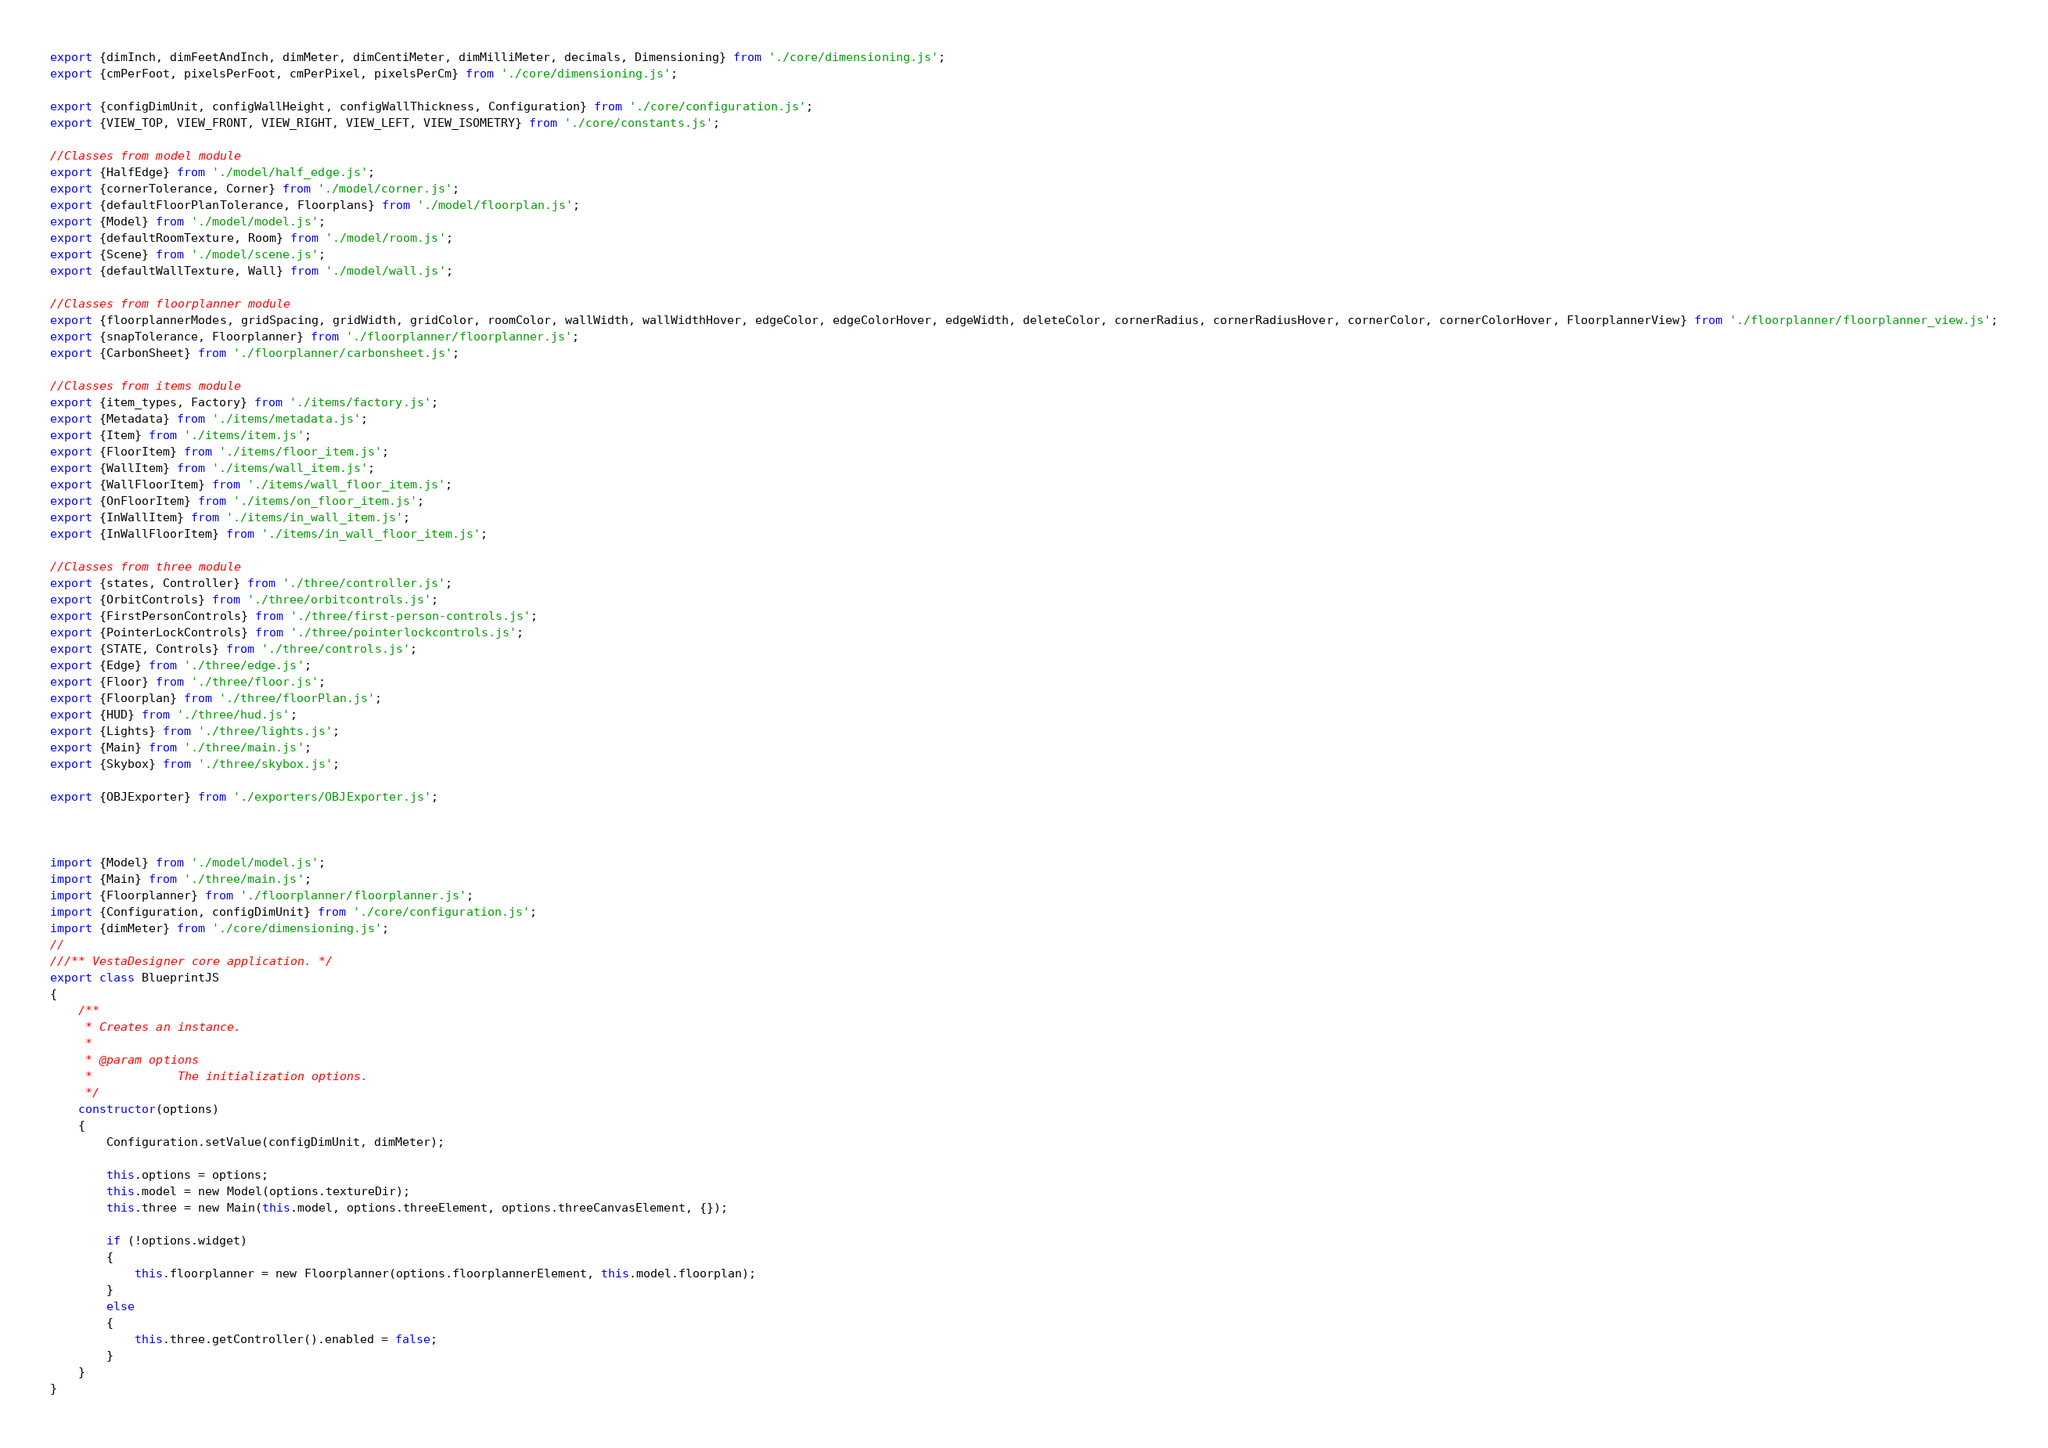<code> <loc_0><loc_0><loc_500><loc_500><_JavaScript_>export {dimInch, dimFeetAndInch, dimMeter, dimCentiMeter, dimMilliMeter, decimals, Dimensioning} from './core/dimensioning.js';
export {cmPerFoot, pixelsPerFoot, cmPerPixel, pixelsPerCm} from './core/dimensioning.js';

export {configDimUnit, configWallHeight, configWallThickness, Configuration} from './core/configuration.js';
export {VIEW_TOP, VIEW_FRONT, VIEW_RIGHT, VIEW_LEFT, VIEW_ISOMETRY} from './core/constants.js';

//Classes from model module
export {HalfEdge} from './model/half_edge.js';
export {cornerTolerance, Corner} from './model/corner.js';
export {defaultFloorPlanTolerance, Floorplans} from './model/floorplan.js';
export {Model} from './model/model.js';
export {defaultRoomTexture, Room} from './model/room.js';
export {Scene} from './model/scene.js';
export {defaultWallTexture, Wall} from './model/wall.js';

//Classes from floorplanner module
export {floorplannerModes, gridSpacing, gridWidth, gridColor, roomColor, wallWidth, wallWidthHover, edgeColor, edgeColorHover, edgeWidth, deleteColor, cornerRadius, cornerRadiusHover, cornerColor, cornerColorHover, FloorplannerView} from './floorplanner/floorplanner_view.js';
export {snapTolerance, Floorplanner} from './floorplanner/floorplanner.js';
export {CarbonSheet} from './floorplanner/carbonsheet.js';

//Classes from items module
export {item_types, Factory} from './items/factory.js';
export {Metadata} from './items/metadata.js';
export {Item} from './items/item.js';
export {FloorItem} from './items/floor_item.js';
export {WallItem} from './items/wall_item.js';
export {WallFloorItem} from './items/wall_floor_item.js';
export {OnFloorItem} from './items/on_floor_item.js';
export {InWallItem} from './items/in_wall_item.js';
export {InWallFloorItem} from './items/in_wall_floor_item.js';

//Classes from three module
export {states, Controller} from './three/controller.js';
export {OrbitControls} from './three/orbitcontrols.js';
export {FirstPersonControls} from './three/first-person-controls.js';
export {PointerLockControls} from './three/pointerlockcontrols.js';
export {STATE, Controls} from './three/controls.js';
export {Edge} from './three/edge.js';
export {Floor} from './three/floor.js';
export {Floorplan} from './three/floorPlan.js';
export {HUD} from './three/hud.js';
export {Lights} from './three/lights.js';
export {Main} from './three/main.js';
export {Skybox} from './three/skybox.js';

export {OBJExporter} from './exporters/OBJExporter.js';



import {Model} from './model/model.js';
import {Main} from './three/main.js';
import {Floorplanner} from './floorplanner/floorplanner.js';
import {Configuration, configDimUnit} from './core/configuration.js';
import {dimMeter} from './core/dimensioning.js';
//
///** VestaDesigner core application. */
export class BlueprintJS 
{
	/**
	 * Creates an instance.
	 * 
	 * @param options
	 *            The initialization options.
	 */
	constructor(options) 
	{
		Configuration.setValue(configDimUnit, dimMeter);
		
		this.options = options;
		this.model = new Model(options.textureDir);
		this.three = new Main(this.model, options.threeElement, options.threeCanvasElement, {});
		
		if (!options.widget) 
		{
			this.floorplanner = new Floorplanner(options.floorplannerElement, this.model.floorplan);
		}
		else 
		{
			this.three.getController().enabled = false;
		}
	}
}
</code> 